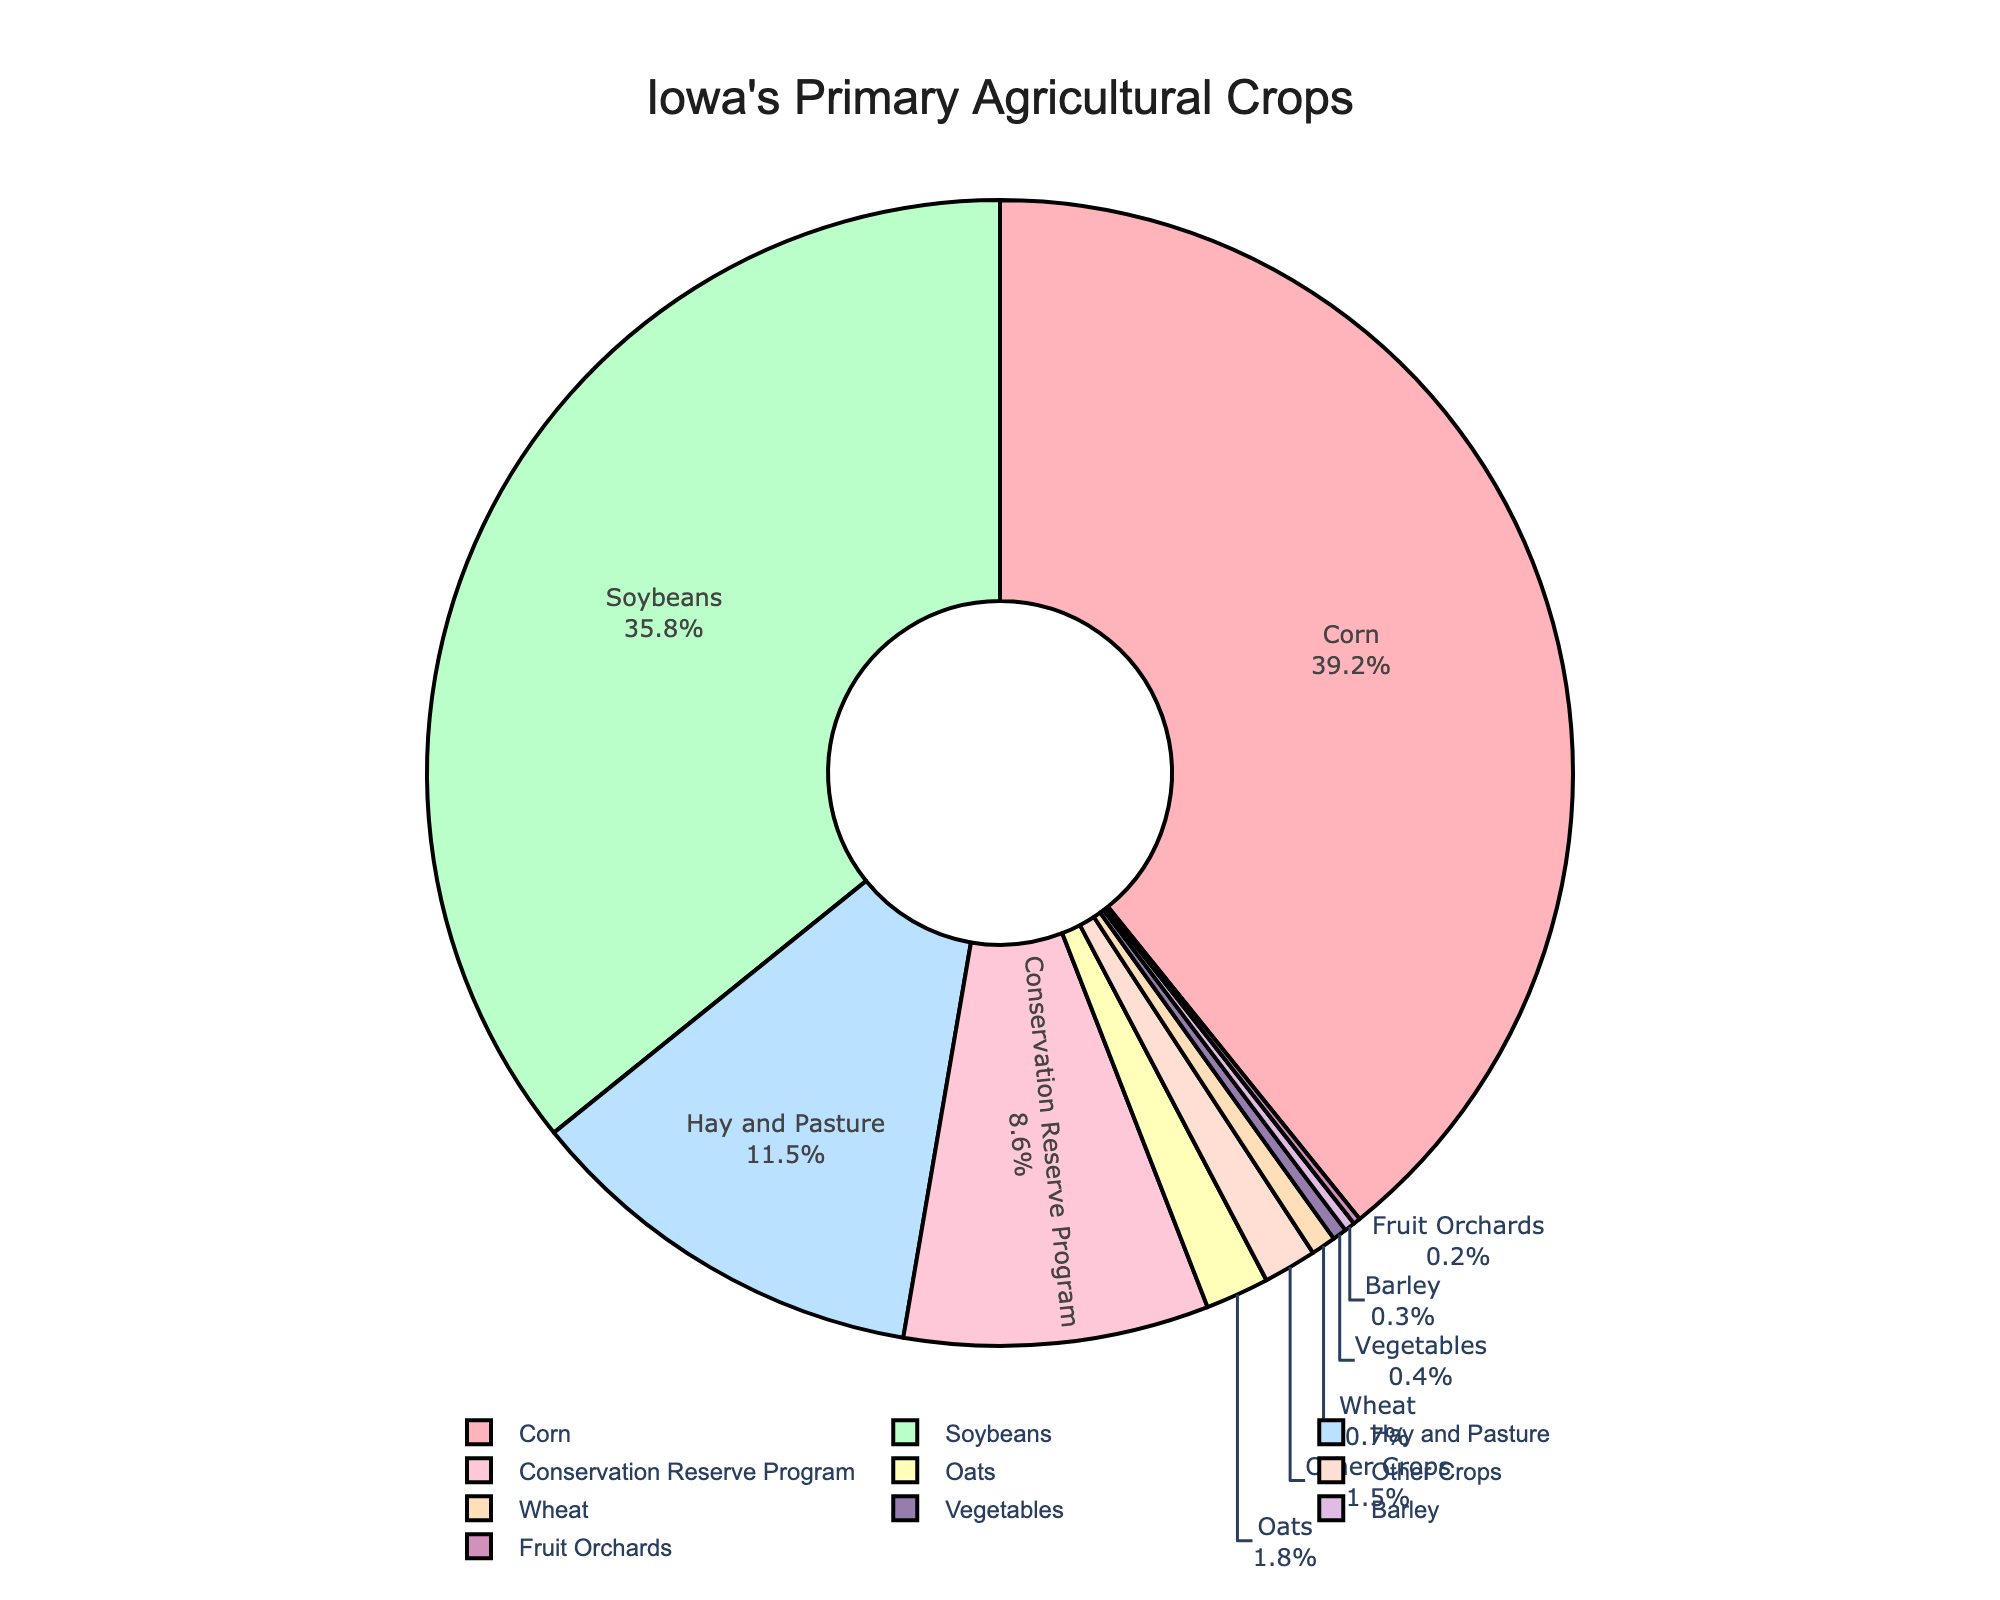What crop uses the largest percentage of Iowa's farmland? The figure shows various crops with their corresponding percentages. Corn has the largest percentage, occupying 39.2% of the total farmland.
Answer: Corn Which crop has a slightly smaller land usage compared to corn? By referring to the chart, the crop with the next highest land usage after corn is soybeans, which uses 35.8%.
Answer: Soybeans How much more farmland is used for hay and pasture compared to oats? The figure shows that hay and pasture uses 11.5% of the land, while oats use 1.8%. The difference is 11.5% - 1.8% = 9.7%.
Answer: 9.7% Which crops combined occupy less than 1% of the total farmland? The figure shows that wheat (0.7%), barley (0.3%), vegetables (0.4%), and fruit orchards (0.2%) each occupy less than 1%.
Answer: Wheat, Barley, Vegetables, Fruit Orchards If you were to group soybeans and conservation reserve program land together, what percentage of total farmland would that be? The chart indicates soybeans use 35.8% and the conservation reserve program uses 8.6%. The combined percentage is 35.8% + 8.6% = 44.4%.
Answer: 44.4% What category occupies more land: hay and pasture or the conservation reserve program? By looking at the chart, hay and pasture occupies 11.5% whereas the conservation reserve program occupies 8.6%. Hay and pasture has a higher land usage.
Answer: Hay and Pasture How do the percentages of corn and soybeans together compare to the rest of the crops combined? Corn and soybeans occupy 39.2% and 35.8% respectively. Combined, they occupy 39.2% + 35.8% = 75%. The remaining crops occupy 25% of the farmland.
Answer: Corn and Soybeans are greater What is the smallest crop category in terms of land usage? The smallest crop category according to the chart is fruit orchards, occupying just 0.2% of the farmland.
Answer: Fruit Orchards 